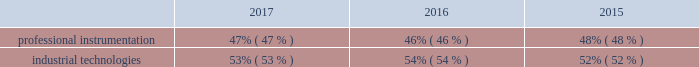The new york stock exchange ( the 201cseparation 201d ) .
The separation was effectuated through a pro-rata dividend distribution on july 2 , 2016 of all of the then-outstanding shares of common stock of fortive corporation to the holders of common stock of danaher as of june 15 , 2016 .
In this annual report , the terms 201cfortive 201d or the 201ccompany 201d refer to either fortive corporation or to fortive corporation and its consolidated subsidiaries , as the context requires .
Reportable segments the table below describes the percentage of sales attributable to each of our two segments over each of the last three years ended december 31 , 2017 .
For additional information regarding sales , operating profit and identifiable assets by segment , please refer to note 17 to the consolidated and combined financial statements included in this annual report. .
Professional instrumentation our professional instrumentation segment offers essential products , software and services used to create actionable intelligence by measuring and monitoring a wide range of physical parameters in industrial applications , including electrical current , radio frequency signals , distance , pressure , temperature , radiation , and hazardous gases .
Customers for these products and services include industrial service , installation and maintenance professionals , designers and manufacturers of electronic devices and instruments , medical technicians , safety professionals and other customers for whom precision , reliability and safety are critical in their specific applications .
2017 sales for this segment by geographic destination were : north america , 50% ( 50 % ) ; europe , 18% ( 18 % ) ; asia pacific , 26% ( 26 % ) , and all other regions , 6% ( 6 % ) .
Our professional instrumentation segment consists of our advanced instrumentation & solutions and sensing technologies businesses .
Our advanced instrumentation & solutions business was primarily established through the acquisitions of qualitrol in the 1980s , fluke corporation in 1998 , pacific scientific company in 1998 , tektronix in 2007 , invetech in 2007 , keithley instruments in 2010 , emaint in 2016 , industrial scientific in 2017 , landauer in 2017 and numerous bolt-on acquisitions .
Advanced instrumentation & solutions our advanced instrumentation & solutions business consists of : field solutions our field solutions products include a variety of compact professional test tools , thermal imaging and calibration equipment for electrical , industrial , electronic and calibration applications , online condition-based monitoring equipment ; portable gas detection equipment , consumables , and software as a service ( saas ) offerings including safety/user behavior , asset management , and compliance monitoring ; subscription-based technical , analytical , and compliance services to determine occupational and environmental radiation exposure ; and computerized maintenance management software for critical infrastructure in utility , industrial , energy , construction , public safety , mining , and healthcare applications .
These products and associated software solutions measure voltage , current , resistance , power quality , frequency , pressure , temperature , radiation , hazardous gas and air quality , among other parameters .
Typical users of these products and software include electrical engineers , electricians , electronic technicians , safety professionals , medical technicians , network technicians , first-responders , and industrial service , installation and maintenance professionals .
The business also makes and sells instruments , controls and monitoring and maintenance systems used by maintenance departments in utilities and industrial facilities to monitor assets , including transformers , generators , motors and switchgear .
Products are marketed under a variety of brands , including fluke , fluke biomedical , fluke networks , industrial scientific , landauer and qualitrol .
Product realization our product realization services and products help developers and engineers across the end-to-end product creation cycle from concepts to finished products .
Our test , measurement and monitoring products are used in the design , manufacturing and development of electronics , industrial , video and other advanced technologies .
Typical users of these products and services include research and development engineers who design , de-bug , monitor and validate the function and performance of electronic components , subassemblies and end-products , and video equipment manufacturers , content developers and broadcasters .
The business also provides a full range of design , engineering and manufacturing services and highly-engineered , modular components to enable conceptualization , development and launch of products in the medical diagnostics , cell therapy and consumer markets .
Finally , the business designs , develops , manufactures and markets critical , highly-engineered energetic materials components in specialized vertical applications .
Products and services are marketed .
What was the change in percentage of sales attributable to industrial technologies from 2016 to 2017? 
Computations: (53% - 54%)
Answer: -0.01. 